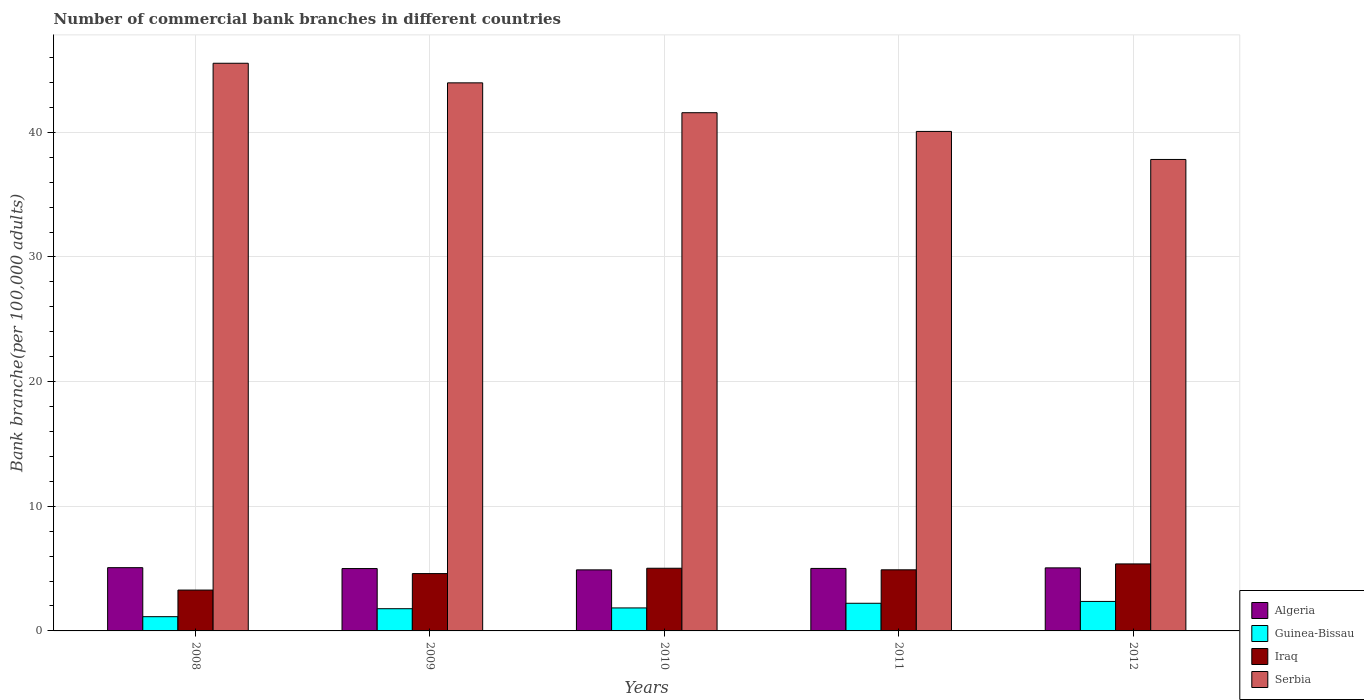How many different coloured bars are there?
Your response must be concise. 4. How many groups of bars are there?
Your answer should be very brief. 5. Are the number of bars per tick equal to the number of legend labels?
Your response must be concise. Yes. How many bars are there on the 1st tick from the right?
Make the answer very short. 4. What is the number of commercial bank branches in Algeria in 2010?
Ensure brevity in your answer.  4.9. Across all years, what is the maximum number of commercial bank branches in Iraq?
Your answer should be compact. 5.38. Across all years, what is the minimum number of commercial bank branches in Iraq?
Your answer should be compact. 3.28. In which year was the number of commercial bank branches in Iraq minimum?
Provide a succinct answer. 2008. What is the total number of commercial bank branches in Algeria in the graph?
Your answer should be very brief. 25.05. What is the difference between the number of commercial bank branches in Guinea-Bissau in 2010 and that in 2012?
Offer a very short reply. -0.52. What is the difference between the number of commercial bank branches in Serbia in 2011 and the number of commercial bank branches in Algeria in 2008?
Make the answer very short. 35. What is the average number of commercial bank branches in Iraq per year?
Provide a succinct answer. 4.64. In the year 2009, what is the difference between the number of commercial bank branches in Guinea-Bissau and number of commercial bank branches in Serbia?
Offer a terse response. -42.19. What is the ratio of the number of commercial bank branches in Iraq in 2008 to that in 2009?
Offer a terse response. 0.71. Is the number of commercial bank branches in Guinea-Bissau in 2011 less than that in 2012?
Your response must be concise. Yes. What is the difference between the highest and the second highest number of commercial bank branches in Guinea-Bissau?
Keep it short and to the point. 0.15. What is the difference between the highest and the lowest number of commercial bank branches in Guinea-Bissau?
Provide a succinct answer. 1.22. In how many years, is the number of commercial bank branches in Serbia greater than the average number of commercial bank branches in Serbia taken over all years?
Your answer should be very brief. 2. Is it the case that in every year, the sum of the number of commercial bank branches in Iraq and number of commercial bank branches in Algeria is greater than the sum of number of commercial bank branches in Guinea-Bissau and number of commercial bank branches in Serbia?
Ensure brevity in your answer.  No. What does the 3rd bar from the left in 2012 represents?
Your answer should be compact. Iraq. What does the 3rd bar from the right in 2008 represents?
Provide a short and direct response. Guinea-Bissau. Are all the bars in the graph horizontal?
Provide a succinct answer. No. How many years are there in the graph?
Provide a succinct answer. 5. What is the difference between two consecutive major ticks on the Y-axis?
Make the answer very short. 10. Does the graph contain any zero values?
Your answer should be very brief. No. How are the legend labels stacked?
Offer a very short reply. Vertical. What is the title of the graph?
Offer a very short reply. Number of commercial bank branches in different countries. Does "Peru" appear as one of the legend labels in the graph?
Give a very brief answer. No. What is the label or title of the X-axis?
Give a very brief answer. Years. What is the label or title of the Y-axis?
Keep it short and to the point. Bank branche(per 100,0 adults). What is the Bank branche(per 100,000 adults) in Algeria in 2008?
Your response must be concise. 5.07. What is the Bank branche(per 100,000 adults) of Guinea-Bissau in 2008?
Ensure brevity in your answer.  1.14. What is the Bank branche(per 100,000 adults) of Iraq in 2008?
Provide a short and direct response. 3.28. What is the Bank branche(per 100,000 adults) of Serbia in 2008?
Offer a terse response. 45.54. What is the Bank branche(per 100,000 adults) in Algeria in 2009?
Provide a short and direct response. 5. What is the Bank branche(per 100,000 adults) in Guinea-Bissau in 2009?
Your response must be concise. 1.78. What is the Bank branche(per 100,000 adults) of Iraq in 2009?
Offer a very short reply. 4.6. What is the Bank branche(per 100,000 adults) in Serbia in 2009?
Provide a succinct answer. 43.97. What is the Bank branche(per 100,000 adults) of Algeria in 2010?
Give a very brief answer. 4.9. What is the Bank branche(per 100,000 adults) of Guinea-Bissau in 2010?
Make the answer very short. 1.84. What is the Bank branche(per 100,000 adults) in Iraq in 2010?
Offer a terse response. 5.03. What is the Bank branche(per 100,000 adults) of Serbia in 2010?
Your answer should be compact. 41.57. What is the Bank branche(per 100,000 adults) of Algeria in 2011?
Offer a terse response. 5.01. What is the Bank branche(per 100,000 adults) of Guinea-Bissau in 2011?
Your answer should be very brief. 2.22. What is the Bank branche(per 100,000 adults) in Iraq in 2011?
Your answer should be very brief. 4.9. What is the Bank branche(per 100,000 adults) in Serbia in 2011?
Keep it short and to the point. 40.07. What is the Bank branche(per 100,000 adults) in Algeria in 2012?
Give a very brief answer. 5.06. What is the Bank branche(per 100,000 adults) of Guinea-Bissau in 2012?
Your response must be concise. 2.37. What is the Bank branche(per 100,000 adults) of Iraq in 2012?
Your response must be concise. 5.38. What is the Bank branche(per 100,000 adults) of Serbia in 2012?
Offer a very short reply. 37.82. Across all years, what is the maximum Bank branche(per 100,000 adults) in Algeria?
Make the answer very short. 5.07. Across all years, what is the maximum Bank branche(per 100,000 adults) of Guinea-Bissau?
Give a very brief answer. 2.37. Across all years, what is the maximum Bank branche(per 100,000 adults) of Iraq?
Your answer should be compact. 5.38. Across all years, what is the maximum Bank branche(per 100,000 adults) of Serbia?
Keep it short and to the point. 45.54. Across all years, what is the minimum Bank branche(per 100,000 adults) of Algeria?
Make the answer very short. 4.9. Across all years, what is the minimum Bank branche(per 100,000 adults) in Guinea-Bissau?
Your answer should be compact. 1.14. Across all years, what is the minimum Bank branche(per 100,000 adults) of Iraq?
Your response must be concise. 3.28. Across all years, what is the minimum Bank branche(per 100,000 adults) of Serbia?
Provide a succinct answer. 37.82. What is the total Bank branche(per 100,000 adults) in Algeria in the graph?
Your answer should be very brief. 25.05. What is the total Bank branche(per 100,000 adults) in Guinea-Bissau in the graph?
Provide a short and direct response. 9.35. What is the total Bank branche(per 100,000 adults) of Iraq in the graph?
Keep it short and to the point. 23.18. What is the total Bank branche(per 100,000 adults) in Serbia in the graph?
Offer a very short reply. 208.98. What is the difference between the Bank branche(per 100,000 adults) of Algeria in 2008 and that in 2009?
Make the answer very short. 0.07. What is the difference between the Bank branche(per 100,000 adults) of Guinea-Bissau in 2008 and that in 2009?
Provide a succinct answer. -0.64. What is the difference between the Bank branche(per 100,000 adults) in Iraq in 2008 and that in 2009?
Offer a terse response. -1.32. What is the difference between the Bank branche(per 100,000 adults) in Serbia in 2008 and that in 2009?
Your answer should be compact. 1.57. What is the difference between the Bank branche(per 100,000 adults) in Algeria in 2008 and that in 2010?
Offer a very short reply. 0.18. What is the difference between the Bank branche(per 100,000 adults) of Guinea-Bissau in 2008 and that in 2010?
Provide a short and direct response. -0.7. What is the difference between the Bank branche(per 100,000 adults) of Iraq in 2008 and that in 2010?
Your response must be concise. -1.75. What is the difference between the Bank branche(per 100,000 adults) in Serbia in 2008 and that in 2010?
Your answer should be very brief. 3.97. What is the difference between the Bank branche(per 100,000 adults) of Algeria in 2008 and that in 2011?
Provide a short and direct response. 0.06. What is the difference between the Bank branche(per 100,000 adults) of Guinea-Bissau in 2008 and that in 2011?
Your answer should be very brief. -1.08. What is the difference between the Bank branche(per 100,000 adults) in Iraq in 2008 and that in 2011?
Offer a terse response. -1.62. What is the difference between the Bank branche(per 100,000 adults) of Serbia in 2008 and that in 2011?
Keep it short and to the point. 5.47. What is the difference between the Bank branche(per 100,000 adults) in Algeria in 2008 and that in 2012?
Provide a succinct answer. 0.02. What is the difference between the Bank branche(per 100,000 adults) of Guinea-Bissau in 2008 and that in 2012?
Ensure brevity in your answer.  -1.22. What is the difference between the Bank branche(per 100,000 adults) of Iraq in 2008 and that in 2012?
Offer a terse response. -2.1. What is the difference between the Bank branche(per 100,000 adults) of Serbia in 2008 and that in 2012?
Offer a very short reply. 7.72. What is the difference between the Bank branche(per 100,000 adults) in Algeria in 2009 and that in 2010?
Ensure brevity in your answer.  0.11. What is the difference between the Bank branche(per 100,000 adults) in Guinea-Bissau in 2009 and that in 2010?
Provide a short and direct response. -0.06. What is the difference between the Bank branche(per 100,000 adults) of Iraq in 2009 and that in 2010?
Your answer should be very brief. -0.43. What is the difference between the Bank branche(per 100,000 adults) of Serbia in 2009 and that in 2010?
Offer a terse response. 2.4. What is the difference between the Bank branche(per 100,000 adults) in Algeria in 2009 and that in 2011?
Keep it short and to the point. -0.01. What is the difference between the Bank branche(per 100,000 adults) in Guinea-Bissau in 2009 and that in 2011?
Keep it short and to the point. -0.44. What is the difference between the Bank branche(per 100,000 adults) of Iraq in 2009 and that in 2011?
Provide a succinct answer. -0.3. What is the difference between the Bank branche(per 100,000 adults) in Serbia in 2009 and that in 2011?
Offer a very short reply. 3.9. What is the difference between the Bank branche(per 100,000 adults) of Algeria in 2009 and that in 2012?
Your response must be concise. -0.06. What is the difference between the Bank branche(per 100,000 adults) of Guinea-Bissau in 2009 and that in 2012?
Provide a short and direct response. -0.58. What is the difference between the Bank branche(per 100,000 adults) in Iraq in 2009 and that in 2012?
Offer a very short reply. -0.78. What is the difference between the Bank branche(per 100,000 adults) in Serbia in 2009 and that in 2012?
Keep it short and to the point. 6.15. What is the difference between the Bank branche(per 100,000 adults) in Algeria in 2010 and that in 2011?
Your answer should be very brief. -0.12. What is the difference between the Bank branche(per 100,000 adults) of Guinea-Bissau in 2010 and that in 2011?
Provide a short and direct response. -0.37. What is the difference between the Bank branche(per 100,000 adults) of Iraq in 2010 and that in 2011?
Offer a terse response. 0.13. What is the difference between the Bank branche(per 100,000 adults) in Serbia in 2010 and that in 2011?
Give a very brief answer. 1.5. What is the difference between the Bank branche(per 100,000 adults) in Algeria in 2010 and that in 2012?
Offer a terse response. -0.16. What is the difference between the Bank branche(per 100,000 adults) of Guinea-Bissau in 2010 and that in 2012?
Your answer should be very brief. -0.52. What is the difference between the Bank branche(per 100,000 adults) in Iraq in 2010 and that in 2012?
Make the answer very short. -0.35. What is the difference between the Bank branche(per 100,000 adults) of Serbia in 2010 and that in 2012?
Your response must be concise. 3.75. What is the difference between the Bank branche(per 100,000 adults) in Algeria in 2011 and that in 2012?
Your answer should be compact. -0.05. What is the difference between the Bank branche(per 100,000 adults) in Guinea-Bissau in 2011 and that in 2012?
Make the answer very short. -0.15. What is the difference between the Bank branche(per 100,000 adults) in Iraq in 2011 and that in 2012?
Your response must be concise. -0.47. What is the difference between the Bank branche(per 100,000 adults) of Serbia in 2011 and that in 2012?
Provide a succinct answer. 2.25. What is the difference between the Bank branche(per 100,000 adults) of Algeria in 2008 and the Bank branche(per 100,000 adults) of Guinea-Bissau in 2009?
Offer a terse response. 3.29. What is the difference between the Bank branche(per 100,000 adults) of Algeria in 2008 and the Bank branche(per 100,000 adults) of Iraq in 2009?
Offer a very short reply. 0.47. What is the difference between the Bank branche(per 100,000 adults) of Algeria in 2008 and the Bank branche(per 100,000 adults) of Serbia in 2009?
Give a very brief answer. -38.9. What is the difference between the Bank branche(per 100,000 adults) in Guinea-Bissau in 2008 and the Bank branche(per 100,000 adults) in Iraq in 2009?
Your answer should be very brief. -3.46. What is the difference between the Bank branche(per 100,000 adults) in Guinea-Bissau in 2008 and the Bank branche(per 100,000 adults) in Serbia in 2009?
Give a very brief answer. -42.83. What is the difference between the Bank branche(per 100,000 adults) in Iraq in 2008 and the Bank branche(per 100,000 adults) in Serbia in 2009?
Your answer should be very brief. -40.69. What is the difference between the Bank branche(per 100,000 adults) in Algeria in 2008 and the Bank branche(per 100,000 adults) in Guinea-Bissau in 2010?
Provide a succinct answer. 3.23. What is the difference between the Bank branche(per 100,000 adults) in Algeria in 2008 and the Bank branche(per 100,000 adults) in Iraq in 2010?
Give a very brief answer. 0.05. What is the difference between the Bank branche(per 100,000 adults) in Algeria in 2008 and the Bank branche(per 100,000 adults) in Serbia in 2010?
Ensure brevity in your answer.  -36.5. What is the difference between the Bank branche(per 100,000 adults) of Guinea-Bissau in 2008 and the Bank branche(per 100,000 adults) of Iraq in 2010?
Provide a succinct answer. -3.89. What is the difference between the Bank branche(per 100,000 adults) of Guinea-Bissau in 2008 and the Bank branche(per 100,000 adults) of Serbia in 2010?
Provide a short and direct response. -40.43. What is the difference between the Bank branche(per 100,000 adults) in Iraq in 2008 and the Bank branche(per 100,000 adults) in Serbia in 2010?
Offer a terse response. -38.3. What is the difference between the Bank branche(per 100,000 adults) of Algeria in 2008 and the Bank branche(per 100,000 adults) of Guinea-Bissau in 2011?
Your answer should be compact. 2.86. What is the difference between the Bank branche(per 100,000 adults) in Algeria in 2008 and the Bank branche(per 100,000 adults) in Iraq in 2011?
Your answer should be very brief. 0.17. What is the difference between the Bank branche(per 100,000 adults) in Algeria in 2008 and the Bank branche(per 100,000 adults) in Serbia in 2011?
Make the answer very short. -35. What is the difference between the Bank branche(per 100,000 adults) of Guinea-Bissau in 2008 and the Bank branche(per 100,000 adults) of Iraq in 2011?
Ensure brevity in your answer.  -3.76. What is the difference between the Bank branche(per 100,000 adults) of Guinea-Bissau in 2008 and the Bank branche(per 100,000 adults) of Serbia in 2011?
Offer a terse response. -38.93. What is the difference between the Bank branche(per 100,000 adults) of Iraq in 2008 and the Bank branche(per 100,000 adults) of Serbia in 2011?
Offer a very short reply. -36.79. What is the difference between the Bank branche(per 100,000 adults) in Algeria in 2008 and the Bank branche(per 100,000 adults) in Guinea-Bissau in 2012?
Your answer should be compact. 2.71. What is the difference between the Bank branche(per 100,000 adults) of Algeria in 2008 and the Bank branche(per 100,000 adults) of Iraq in 2012?
Offer a terse response. -0.3. What is the difference between the Bank branche(per 100,000 adults) of Algeria in 2008 and the Bank branche(per 100,000 adults) of Serbia in 2012?
Keep it short and to the point. -32.75. What is the difference between the Bank branche(per 100,000 adults) in Guinea-Bissau in 2008 and the Bank branche(per 100,000 adults) in Iraq in 2012?
Offer a terse response. -4.23. What is the difference between the Bank branche(per 100,000 adults) of Guinea-Bissau in 2008 and the Bank branche(per 100,000 adults) of Serbia in 2012?
Your response must be concise. -36.68. What is the difference between the Bank branche(per 100,000 adults) of Iraq in 2008 and the Bank branche(per 100,000 adults) of Serbia in 2012?
Provide a short and direct response. -34.55. What is the difference between the Bank branche(per 100,000 adults) in Algeria in 2009 and the Bank branche(per 100,000 adults) in Guinea-Bissau in 2010?
Offer a very short reply. 3.16. What is the difference between the Bank branche(per 100,000 adults) in Algeria in 2009 and the Bank branche(per 100,000 adults) in Iraq in 2010?
Your answer should be very brief. -0.02. What is the difference between the Bank branche(per 100,000 adults) in Algeria in 2009 and the Bank branche(per 100,000 adults) in Serbia in 2010?
Give a very brief answer. -36.57. What is the difference between the Bank branche(per 100,000 adults) in Guinea-Bissau in 2009 and the Bank branche(per 100,000 adults) in Iraq in 2010?
Your response must be concise. -3.25. What is the difference between the Bank branche(per 100,000 adults) of Guinea-Bissau in 2009 and the Bank branche(per 100,000 adults) of Serbia in 2010?
Make the answer very short. -39.79. What is the difference between the Bank branche(per 100,000 adults) of Iraq in 2009 and the Bank branche(per 100,000 adults) of Serbia in 2010?
Provide a short and direct response. -36.98. What is the difference between the Bank branche(per 100,000 adults) of Algeria in 2009 and the Bank branche(per 100,000 adults) of Guinea-Bissau in 2011?
Provide a succinct answer. 2.79. What is the difference between the Bank branche(per 100,000 adults) of Algeria in 2009 and the Bank branche(per 100,000 adults) of Iraq in 2011?
Make the answer very short. 0.1. What is the difference between the Bank branche(per 100,000 adults) in Algeria in 2009 and the Bank branche(per 100,000 adults) in Serbia in 2011?
Provide a short and direct response. -35.07. What is the difference between the Bank branche(per 100,000 adults) in Guinea-Bissau in 2009 and the Bank branche(per 100,000 adults) in Iraq in 2011?
Give a very brief answer. -3.12. What is the difference between the Bank branche(per 100,000 adults) of Guinea-Bissau in 2009 and the Bank branche(per 100,000 adults) of Serbia in 2011?
Your answer should be compact. -38.29. What is the difference between the Bank branche(per 100,000 adults) of Iraq in 2009 and the Bank branche(per 100,000 adults) of Serbia in 2011?
Ensure brevity in your answer.  -35.47. What is the difference between the Bank branche(per 100,000 adults) in Algeria in 2009 and the Bank branche(per 100,000 adults) in Guinea-Bissau in 2012?
Your answer should be very brief. 2.64. What is the difference between the Bank branche(per 100,000 adults) in Algeria in 2009 and the Bank branche(per 100,000 adults) in Iraq in 2012?
Give a very brief answer. -0.37. What is the difference between the Bank branche(per 100,000 adults) in Algeria in 2009 and the Bank branche(per 100,000 adults) in Serbia in 2012?
Ensure brevity in your answer.  -32.82. What is the difference between the Bank branche(per 100,000 adults) of Guinea-Bissau in 2009 and the Bank branche(per 100,000 adults) of Iraq in 2012?
Your response must be concise. -3.59. What is the difference between the Bank branche(per 100,000 adults) of Guinea-Bissau in 2009 and the Bank branche(per 100,000 adults) of Serbia in 2012?
Give a very brief answer. -36.04. What is the difference between the Bank branche(per 100,000 adults) in Iraq in 2009 and the Bank branche(per 100,000 adults) in Serbia in 2012?
Keep it short and to the point. -33.22. What is the difference between the Bank branche(per 100,000 adults) in Algeria in 2010 and the Bank branche(per 100,000 adults) in Guinea-Bissau in 2011?
Your answer should be compact. 2.68. What is the difference between the Bank branche(per 100,000 adults) of Algeria in 2010 and the Bank branche(per 100,000 adults) of Iraq in 2011?
Offer a very short reply. -0. What is the difference between the Bank branche(per 100,000 adults) in Algeria in 2010 and the Bank branche(per 100,000 adults) in Serbia in 2011?
Offer a very short reply. -35.17. What is the difference between the Bank branche(per 100,000 adults) in Guinea-Bissau in 2010 and the Bank branche(per 100,000 adults) in Iraq in 2011?
Provide a short and direct response. -3.06. What is the difference between the Bank branche(per 100,000 adults) of Guinea-Bissau in 2010 and the Bank branche(per 100,000 adults) of Serbia in 2011?
Make the answer very short. -38.23. What is the difference between the Bank branche(per 100,000 adults) of Iraq in 2010 and the Bank branche(per 100,000 adults) of Serbia in 2011?
Your answer should be very brief. -35.04. What is the difference between the Bank branche(per 100,000 adults) in Algeria in 2010 and the Bank branche(per 100,000 adults) in Guinea-Bissau in 2012?
Provide a short and direct response. 2.53. What is the difference between the Bank branche(per 100,000 adults) of Algeria in 2010 and the Bank branche(per 100,000 adults) of Iraq in 2012?
Ensure brevity in your answer.  -0.48. What is the difference between the Bank branche(per 100,000 adults) of Algeria in 2010 and the Bank branche(per 100,000 adults) of Serbia in 2012?
Your answer should be compact. -32.93. What is the difference between the Bank branche(per 100,000 adults) of Guinea-Bissau in 2010 and the Bank branche(per 100,000 adults) of Iraq in 2012?
Keep it short and to the point. -3.53. What is the difference between the Bank branche(per 100,000 adults) in Guinea-Bissau in 2010 and the Bank branche(per 100,000 adults) in Serbia in 2012?
Your answer should be very brief. -35.98. What is the difference between the Bank branche(per 100,000 adults) of Iraq in 2010 and the Bank branche(per 100,000 adults) of Serbia in 2012?
Offer a very short reply. -32.8. What is the difference between the Bank branche(per 100,000 adults) of Algeria in 2011 and the Bank branche(per 100,000 adults) of Guinea-Bissau in 2012?
Offer a very short reply. 2.65. What is the difference between the Bank branche(per 100,000 adults) of Algeria in 2011 and the Bank branche(per 100,000 adults) of Iraq in 2012?
Your answer should be compact. -0.36. What is the difference between the Bank branche(per 100,000 adults) of Algeria in 2011 and the Bank branche(per 100,000 adults) of Serbia in 2012?
Offer a very short reply. -32.81. What is the difference between the Bank branche(per 100,000 adults) of Guinea-Bissau in 2011 and the Bank branche(per 100,000 adults) of Iraq in 2012?
Make the answer very short. -3.16. What is the difference between the Bank branche(per 100,000 adults) of Guinea-Bissau in 2011 and the Bank branche(per 100,000 adults) of Serbia in 2012?
Make the answer very short. -35.61. What is the difference between the Bank branche(per 100,000 adults) in Iraq in 2011 and the Bank branche(per 100,000 adults) in Serbia in 2012?
Provide a succinct answer. -32.92. What is the average Bank branche(per 100,000 adults) in Algeria per year?
Offer a terse response. 5.01. What is the average Bank branche(per 100,000 adults) in Guinea-Bissau per year?
Offer a terse response. 1.87. What is the average Bank branche(per 100,000 adults) in Iraq per year?
Give a very brief answer. 4.64. What is the average Bank branche(per 100,000 adults) of Serbia per year?
Ensure brevity in your answer.  41.8. In the year 2008, what is the difference between the Bank branche(per 100,000 adults) of Algeria and Bank branche(per 100,000 adults) of Guinea-Bissau?
Provide a succinct answer. 3.93. In the year 2008, what is the difference between the Bank branche(per 100,000 adults) in Algeria and Bank branche(per 100,000 adults) in Iraq?
Give a very brief answer. 1.8. In the year 2008, what is the difference between the Bank branche(per 100,000 adults) of Algeria and Bank branche(per 100,000 adults) of Serbia?
Ensure brevity in your answer.  -40.47. In the year 2008, what is the difference between the Bank branche(per 100,000 adults) of Guinea-Bissau and Bank branche(per 100,000 adults) of Iraq?
Your response must be concise. -2.14. In the year 2008, what is the difference between the Bank branche(per 100,000 adults) of Guinea-Bissau and Bank branche(per 100,000 adults) of Serbia?
Offer a terse response. -44.4. In the year 2008, what is the difference between the Bank branche(per 100,000 adults) of Iraq and Bank branche(per 100,000 adults) of Serbia?
Your answer should be very brief. -42.26. In the year 2009, what is the difference between the Bank branche(per 100,000 adults) in Algeria and Bank branche(per 100,000 adults) in Guinea-Bissau?
Ensure brevity in your answer.  3.22. In the year 2009, what is the difference between the Bank branche(per 100,000 adults) of Algeria and Bank branche(per 100,000 adults) of Iraq?
Ensure brevity in your answer.  0.4. In the year 2009, what is the difference between the Bank branche(per 100,000 adults) in Algeria and Bank branche(per 100,000 adults) in Serbia?
Offer a terse response. -38.97. In the year 2009, what is the difference between the Bank branche(per 100,000 adults) in Guinea-Bissau and Bank branche(per 100,000 adults) in Iraq?
Offer a very short reply. -2.82. In the year 2009, what is the difference between the Bank branche(per 100,000 adults) of Guinea-Bissau and Bank branche(per 100,000 adults) of Serbia?
Your answer should be compact. -42.19. In the year 2009, what is the difference between the Bank branche(per 100,000 adults) in Iraq and Bank branche(per 100,000 adults) in Serbia?
Your answer should be compact. -39.37. In the year 2010, what is the difference between the Bank branche(per 100,000 adults) in Algeria and Bank branche(per 100,000 adults) in Guinea-Bissau?
Make the answer very short. 3.05. In the year 2010, what is the difference between the Bank branche(per 100,000 adults) in Algeria and Bank branche(per 100,000 adults) in Iraq?
Your answer should be compact. -0.13. In the year 2010, what is the difference between the Bank branche(per 100,000 adults) in Algeria and Bank branche(per 100,000 adults) in Serbia?
Provide a short and direct response. -36.68. In the year 2010, what is the difference between the Bank branche(per 100,000 adults) in Guinea-Bissau and Bank branche(per 100,000 adults) in Iraq?
Provide a short and direct response. -3.18. In the year 2010, what is the difference between the Bank branche(per 100,000 adults) of Guinea-Bissau and Bank branche(per 100,000 adults) of Serbia?
Give a very brief answer. -39.73. In the year 2010, what is the difference between the Bank branche(per 100,000 adults) in Iraq and Bank branche(per 100,000 adults) in Serbia?
Offer a very short reply. -36.55. In the year 2011, what is the difference between the Bank branche(per 100,000 adults) of Algeria and Bank branche(per 100,000 adults) of Guinea-Bissau?
Keep it short and to the point. 2.79. In the year 2011, what is the difference between the Bank branche(per 100,000 adults) in Algeria and Bank branche(per 100,000 adults) in Iraq?
Keep it short and to the point. 0.11. In the year 2011, what is the difference between the Bank branche(per 100,000 adults) of Algeria and Bank branche(per 100,000 adults) of Serbia?
Provide a succinct answer. -35.06. In the year 2011, what is the difference between the Bank branche(per 100,000 adults) of Guinea-Bissau and Bank branche(per 100,000 adults) of Iraq?
Make the answer very short. -2.68. In the year 2011, what is the difference between the Bank branche(per 100,000 adults) of Guinea-Bissau and Bank branche(per 100,000 adults) of Serbia?
Ensure brevity in your answer.  -37.85. In the year 2011, what is the difference between the Bank branche(per 100,000 adults) in Iraq and Bank branche(per 100,000 adults) in Serbia?
Your answer should be compact. -35.17. In the year 2012, what is the difference between the Bank branche(per 100,000 adults) in Algeria and Bank branche(per 100,000 adults) in Guinea-Bissau?
Keep it short and to the point. 2.69. In the year 2012, what is the difference between the Bank branche(per 100,000 adults) of Algeria and Bank branche(per 100,000 adults) of Iraq?
Offer a terse response. -0.32. In the year 2012, what is the difference between the Bank branche(per 100,000 adults) in Algeria and Bank branche(per 100,000 adults) in Serbia?
Offer a very short reply. -32.76. In the year 2012, what is the difference between the Bank branche(per 100,000 adults) of Guinea-Bissau and Bank branche(per 100,000 adults) of Iraq?
Provide a short and direct response. -3.01. In the year 2012, what is the difference between the Bank branche(per 100,000 adults) in Guinea-Bissau and Bank branche(per 100,000 adults) in Serbia?
Give a very brief answer. -35.46. In the year 2012, what is the difference between the Bank branche(per 100,000 adults) in Iraq and Bank branche(per 100,000 adults) in Serbia?
Your answer should be compact. -32.45. What is the ratio of the Bank branche(per 100,000 adults) of Algeria in 2008 to that in 2009?
Offer a terse response. 1.01. What is the ratio of the Bank branche(per 100,000 adults) of Guinea-Bissau in 2008 to that in 2009?
Provide a short and direct response. 0.64. What is the ratio of the Bank branche(per 100,000 adults) in Iraq in 2008 to that in 2009?
Ensure brevity in your answer.  0.71. What is the ratio of the Bank branche(per 100,000 adults) in Serbia in 2008 to that in 2009?
Your answer should be compact. 1.04. What is the ratio of the Bank branche(per 100,000 adults) of Algeria in 2008 to that in 2010?
Your response must be concise. 1.04. What is the ratio of the Bank branche(per 100,000 adults) in Guinea-Bissau in 2008 to that in 2010?
Provide a short and direct response. 0.62. What is the ratio of the Bank branche(per 100,000 adults) of Iraq in 2008 to that in 2010?
Ensure brevity in your answer.  0.65. What is the ratio of the Bank branche(per 100,000 adults) of Serbia in 2008 to that in 2010?
Your response must be concise. 1.1. What is the ratio of the Bank branche(per 100,000 adults) of Algeria in 2008 to that in 2011?
Ensure brevity in your answer.  1.01. What is the ratio of the Bank branche(per 100,000 adults) of Guinea-Bissau in 2008 to that in 2011?
Provide a succinct answer. 0.51. What is the ratio of the Bank branche(per 100,000 adults) of Iraq in 2008 to that in 2011?
Keep it short and to the point. 0.67. What is the ratio of the Bank branche(per 100,000 adults) in Serbia in 2008 to that in 2011?
Offer a terse response. 1.14. What is the ratio of the Bank branche(per 100,000 adults) of Algeria in 2008 to that in 2012?
Provide a succinct answer. 1. What is the ratio of the Bank branche(per 100,000 adults) of Guinea-Bissau in 2008 to that in 2012?
Ensure brevity in your answer.  0.48. What is the ratio of the Bank branche(per 100,000 adults) in Iraq in 2008 to that in 2012?
Offer a very short reply. 0.61. What is the ratio of the Bank branche(per 100,000 adults) of Serbia in 2008 to that in 2012?
Offer a terse response. 1.2. What is the ratio of the Bank branche(per 100,000 adults) of Algeria in 2009 to that in 2010?
Your answer should be compact. 1.02. What is the ratio of the Bank branche(per 100,000 adults) in Guinea-Bissau in 2009 to that in 2010?
Offer a very short reply. 0.97. What is the ratio of the Bank branche(per 100,000 adults) of Iraq in 2009 to that in 2010?
Provide a short and direct response. 0.91. What is the ratio of the Bank branche(per 100,000 adults) in Serbia in 2009 to that in 2010?
Your answer should be very brief. 1.06. What is the ratio of the Bank branche(per 100,000 adults) in Algeria in 2009 to that in 2011?
Your response must be concise. 1. What is the ratio of the Bank branche(per 100,000 adults) in Guinea-Bissau in 2009 to that in 2011?
Your answer should be compact. 0.8. What is the ratio of the Bank branche(per 100,000 adults) in Iraq in 2009 to that in 2011?
Your answer should be compact. 0.94. What is the ratio of the Bank branche(per 100,000 adults) of Serbia in 2009 to that in 2011?
Your answer should be very brief. 1.1. What is the ratio of the Bank branche(per 100,000 adults) in Guinea-Bissau in 2009 to that in 2012?
Keep it short and to the point. 0.75. What is the ratio of the Bank branche(per 100,000 adults) in Iraq in 2009 to that in 2012?
Offer a very short reply. 0.86. What is the ratio of the Bank branche(per 100,000 adults) in Serbia in 2009 to that in 2012?
Offer a terse response. 1.16. What is the ratio of the Bank branche(per 100,000 adults) in Algeria in 2010 to that in 2011?
Ensure brevity in your answer.  0.98. What is the ratio of the Bank branche(per 100,000 adults) in Guinea-Bissau in 2010 to that in 2011?
Make the answer very short. 0.83. What is the ratio of the Bank branche(per 100,000 adults) of Iraq in 2010 to that in 2011?
Your answer should be compact. 1.03. What is the ratio of the Bank branche(per 100,000 adults) of Serbia in 2010 to that in 2011?
Your response must be concise. 1.04. What is the ratio of the Bank branche(per 100,000 adults) of Algeria in 2010 to that in 2012?
Keep it short and to the point. 0.97. What is the ratio of the Bank branche(per 100,000 adults) in Guinea-Bissau in 2010 to that in 2012?
Your answer should be compact. 0.78. What is the ratio of the Bank branche(per 100,000 adults) in Iraq in 2010 to that in 2012?
Your answer should be compact. 0.94. What is the ratio of the Bank branche(per 100,000 adults) of Serbia in 2010 to that in 2012?
Keep it short and to the point. 1.1. What is the ratio of the Bank branche(per 100,000 adults) in Guinea-Bissau in 2011 to that in 2012?
Ensure brevity in your answer.  0.94. What is the ratio of the Bank branche(per 100,000 adults) of Iraq in 2011 to that in 2012?
Give a very brief answer. 0.91. What is the ratio of the Bank branche(per 100,000 adults) of Serbia in 2011 to that in 2012?
Provide a short and direct response. 1.06. What is the difference between the highest and the second highest Bank branche(per 100,000 adults) of Algeria?
Provide a short and direct response. 0.02. What is the difference between the highest and the second highest Bank branche(per 100,000 adults) in Guinea-Bissau?
Keep it short and to the point. 0.15. What is the difference between the highest and the second highest Bank branche(per 100,000 adults) of Iraq?
Your answer should be very brief. 0.35. What is the difference between the highest and the second highest Bank branche(per 100,000 adults) in Serbia?
Your answer should be compact. 1.57. What is the difference between the highest and the lowest Bank branche(per 100,000 adults) in Algeria?
Your answer should be very brief. 0.18. What is the difference between the highest and the lowest Bank branche(per 100,000 adults) of Guinea-Bissau?
Your answer should be compact. 1.22. What is the difference between the highest and the lowest Bank branche(per 100,000 adults) of Iraq?
Make the answer very short. 2.1. What is the difference between the highest and the lowest Bank branche(per 100,000 adults) in Serbia?
Provide a short and direct response. 7.72. 